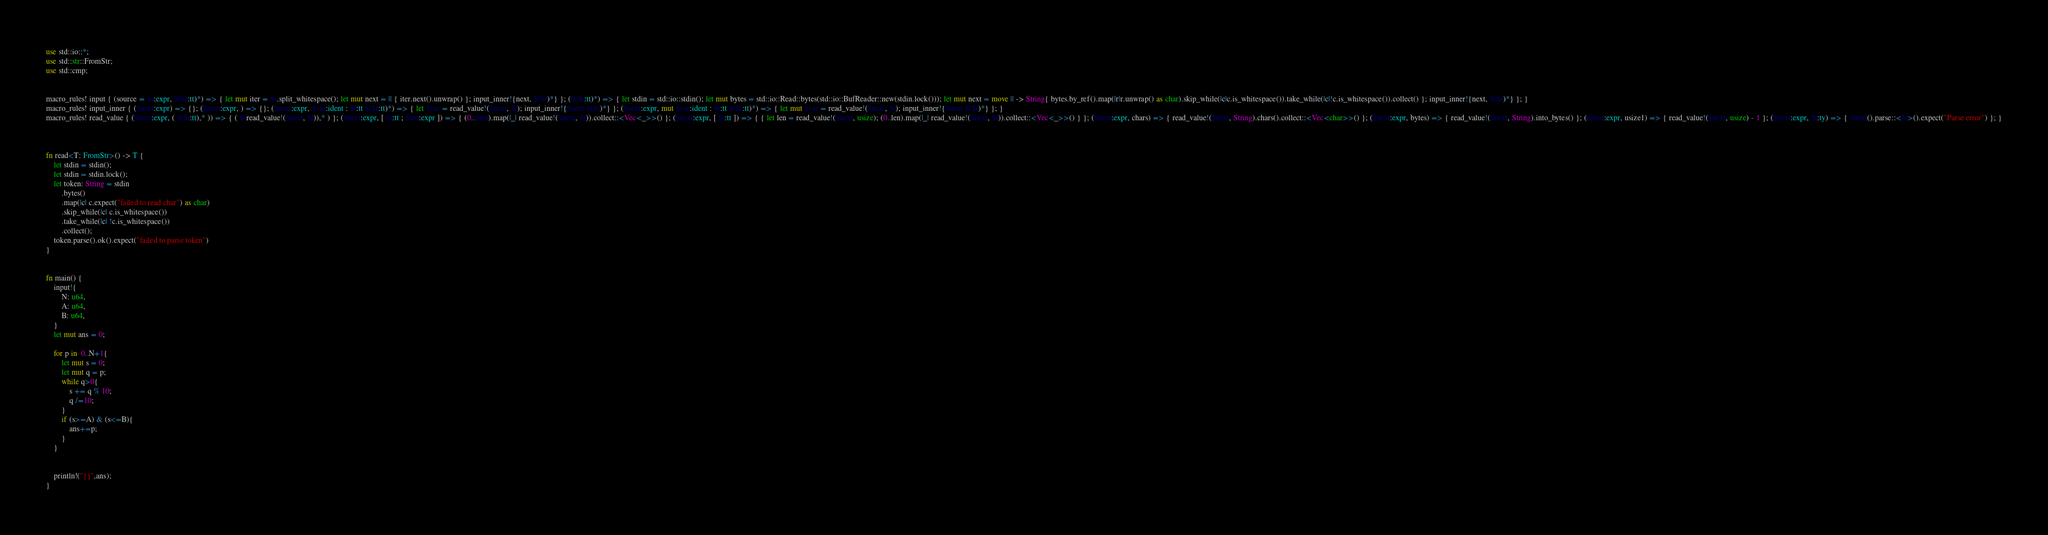Convert code to text. <code><loc_0><loc_0><loc_500><loc_500><_Rust_>use std::io::*;
use std::str::FromStr;
use std::cmp;


macro_rules! input { (source = $s:expr, $($r:tt)*) => { let mut iter = $s.split_whitespace(); let mut next = || { iter.next().unwrap() }; input_inner!{next, $($r)*} }; ($($r:tt)*) => { let stdin = std::io::stdin(); let mut bytes = std::io::Read::bytes(std::io::BufReader::new(stdin.lock())); let mut next = move || -> String{ bytes.by_ref().map(|r|r.unwrap() as char).skip_while(|c|c.is_whitespace()).take_while(|c|!c.is_whitespace()).collect() }; input_inner!{next, $($r)*} }; }
macro_rules! input_inner { ($next:expr) => {}; ($next:expr, ) => {}; ($next:expr, $var:ident : $t:tt $($r:tt)*) => { let $var = read_value!($next, $t); input_inner!{$next $($r)*} }; ($next:expr, mut $var:ident : $t:tt $($r:tt)*) => { let mut $var = read_value!($next, $t); input_inner!{$next $($r)*} }; }
macro_rules! read_value { ($next:expr, ( $($t:tt),* )) => { ( $(read_value!($next, $t)),* ) }; ($next:expr, [ $t:tt ; $len:expr ]) => { (0..$len).map(|_| read_value!($next, $t)).collect::<Vec<_>>() }; ($next:expr, [ $t:tt ]) => { { let len = read_value!($next, usize); (0..len).map(|_| read_value!($next, $t)).collect::<Vec<_>>() } }; ($next:expr, chars) => { read_value!($next, String).chars().collect::<Vec<char>>() }; ($next:expr, bytes) => { read_value!($next, String).into_bytes() }; ($next:expr, usize1) => { read_value!($next, usize) - 1 }; ($next:expr, $t:ty) => { $next().parse::<$t>().expect("Parse error") }; }
 
 

fn read<T: FromStr>() -> T {
    let stdin = stdin();
    let stdin = stdin.lock();
    let token: String = stdin
        .bytes()
        .map(|c| c.expect("failed to read char") as char) 
        .skip_while(|c| c.is_whitespace())
        .take_while(|c| !c.is_whitespace())
        .collect();
    token.parse().ok().expect("failed to parse token")
}


fn main() {
    input!{
        N: u64,
        A: u64,
        B: u64,
    }
    let mut ans = 0;
    
    for p in  0..N+1{
    	let mut s = 0;
        let mut q = p;
    	while q>0{
        	s += q % 10;
        	q /=10;
        }
        if (s>=A) & (s<=B){
        	ans+=p;
        }
    }
    
    
    println!("{}",ans);
}
</code> 